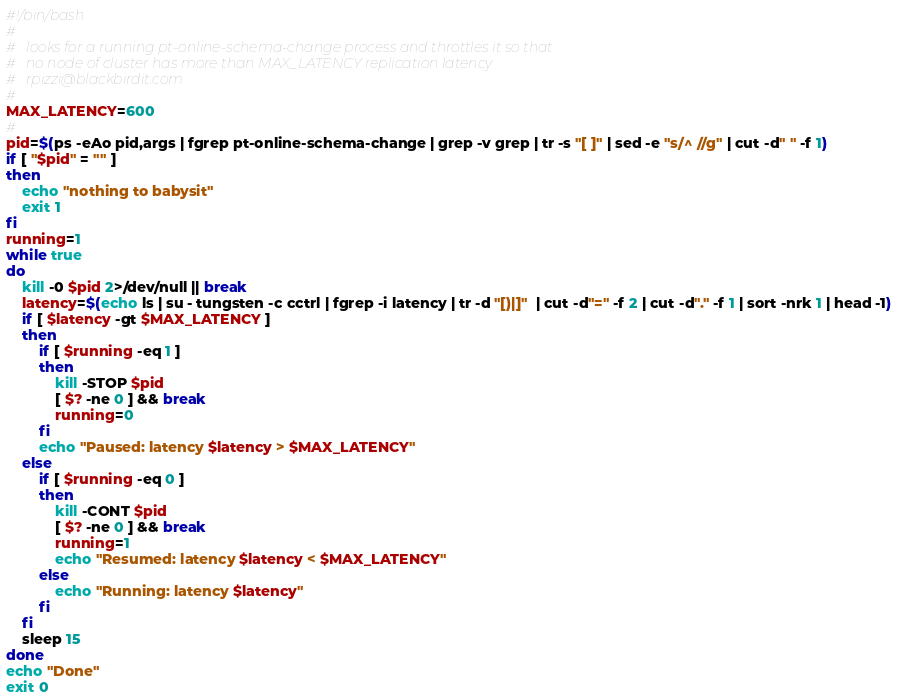<code> <loc_0><loc_0><loc_500><loc_500><_Bash_>#!/bin/bash
#
#	looks for a running pt-online-schema-change process and throttles it so that
#	no node of cluster has more than MAX_LATENCY replication latency
#	rpizzi@blackbirdit.com
#
MAX_LATENCY=600
#
pid=$(ps -eAo pid,args | fgrep pt-online-schema-change | grep -v grep | tr -s "[ ]" | sed -e "s/^ //g" | cut -d" " -f 1)
if [ "$pid" = "" ]
then
	echo "nothing to babysit"
	exit 1
fi
running=1
while true
do
	kill -0 $pid 2>/dev/null || break
	latency=$(echo ls | su - tungsten -c cctrl | fgrep -i latency | tr -d "[)|]"  | cut -d"=" -f 2 | cut -d"." -f 1 | sort -nrk 1 | head -1)
	if [ $latency -gt $MAX_LATENCY ]
	then
		if [ $running -eq 1 ]
		then
			kill -STOP $pid
			[ $? -ne 0 ] && break
			running=0
		fi
		echo "Paused: latency $latency > $MAX_LATENCY"
	else
		if [ $running -eq 0 ]
		then
			kill -CONT $pid
			[ $? -ne 0 ] && break
			running=1
			echo "Resumed: latency $latency < $MAX_LATENCY"
		else
			echo "Running: latency $latency" 
		fi
	fi
	sleep 15
done
echo "Done"
exit 0
</code> 